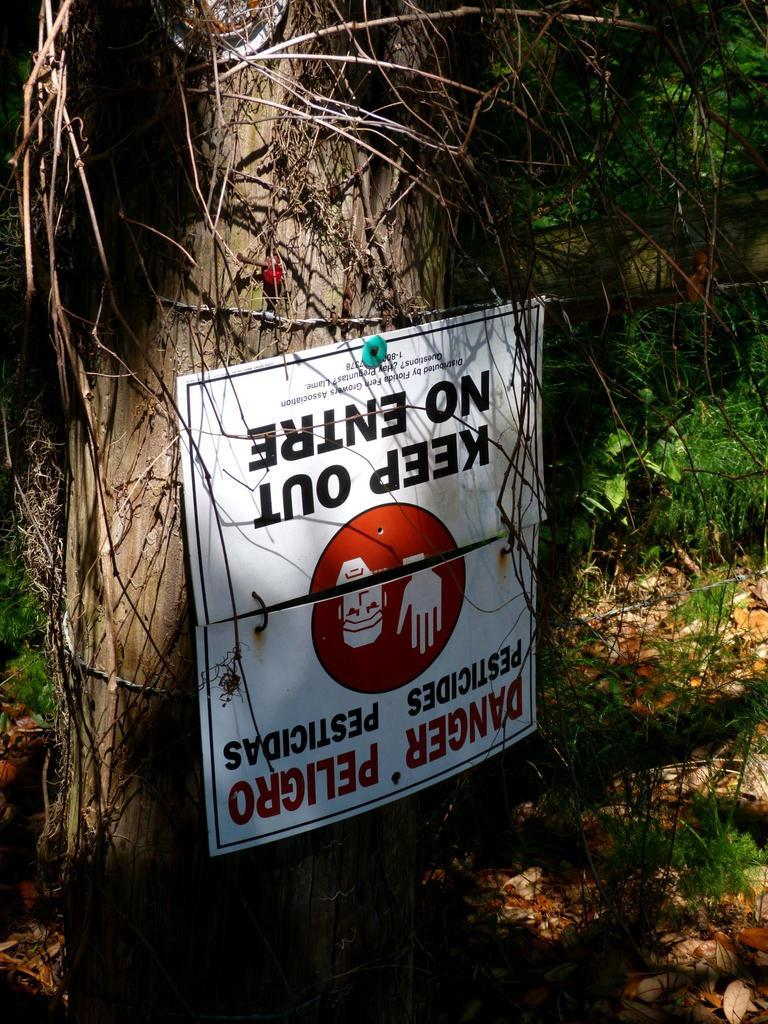What is the main subject in the center of the image? There is a poster in the center of the image. Where is the poster located? The poster is on a tree trunk. What can be seen at the bottom of the image? Dried leaves are present at the bottom of the image. What type of seat is attached to the tree trunk in the image? There is no seat attached to the tree trunk in the image; it only features a poster on the tree trunk and dried leaves at the bottom. 